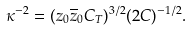Convert formula to latex. <formula><loc_0><loc_0><loc_500><loc_500>\kappa ^ { - 2 } = ( z _ { 0 } \overline { z } _ { 0 } C _ { T } ) ^ { 3 / 2 } ( 2 C ) ^ { - 1 / 2 } .</formula> 